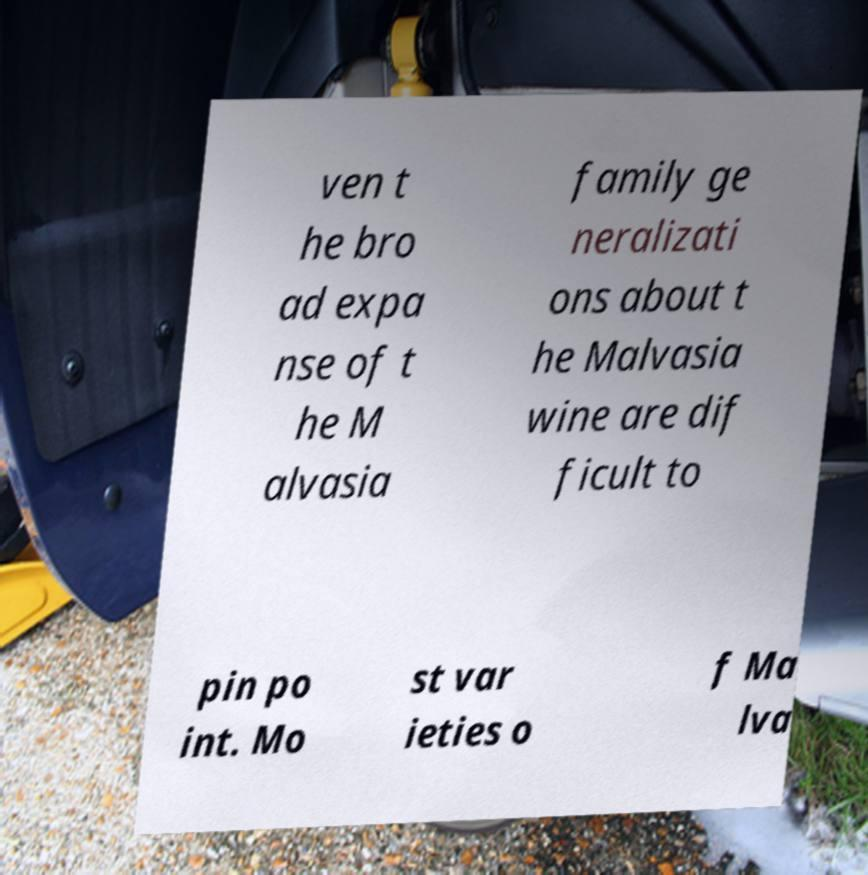I need the written content from this picture converted into text. Can you do that? ven t he bro ad expa nse of t he M alvasia family ge neralizati ons about t he Malvasia wine are dif ficult to pin po int. Mo st var ieties o f Ma lva 